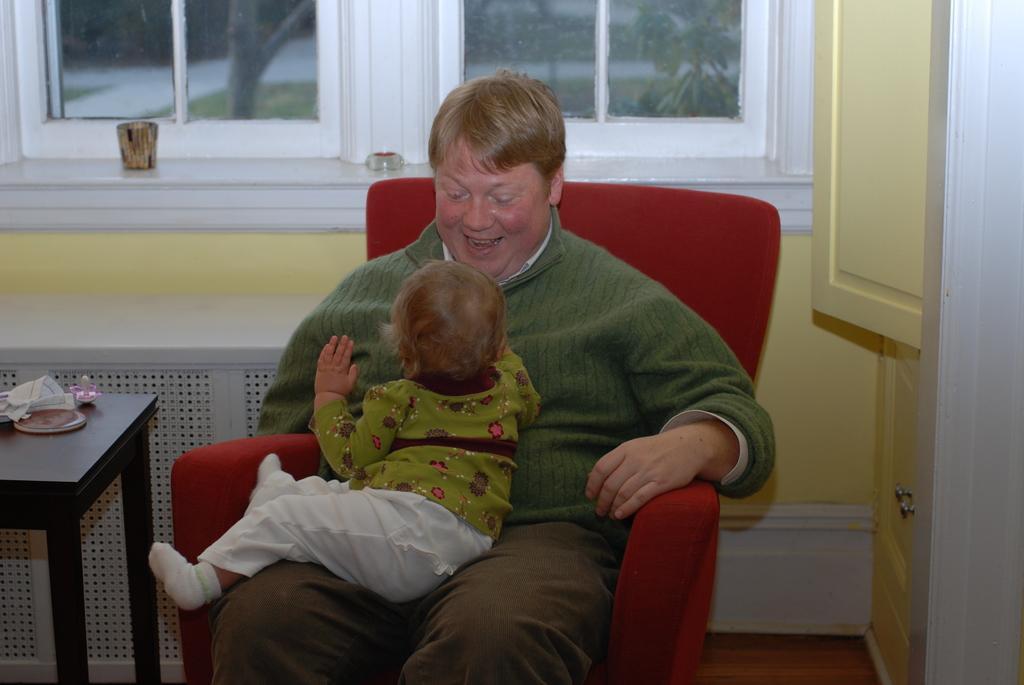Can you describe this image briefly? Here we can see that a man sitting on the chair and smiling, and a baby in front, and at side there is the table and some objects on it, and at back there is window, and we can see trees at back, and here is the wall. 